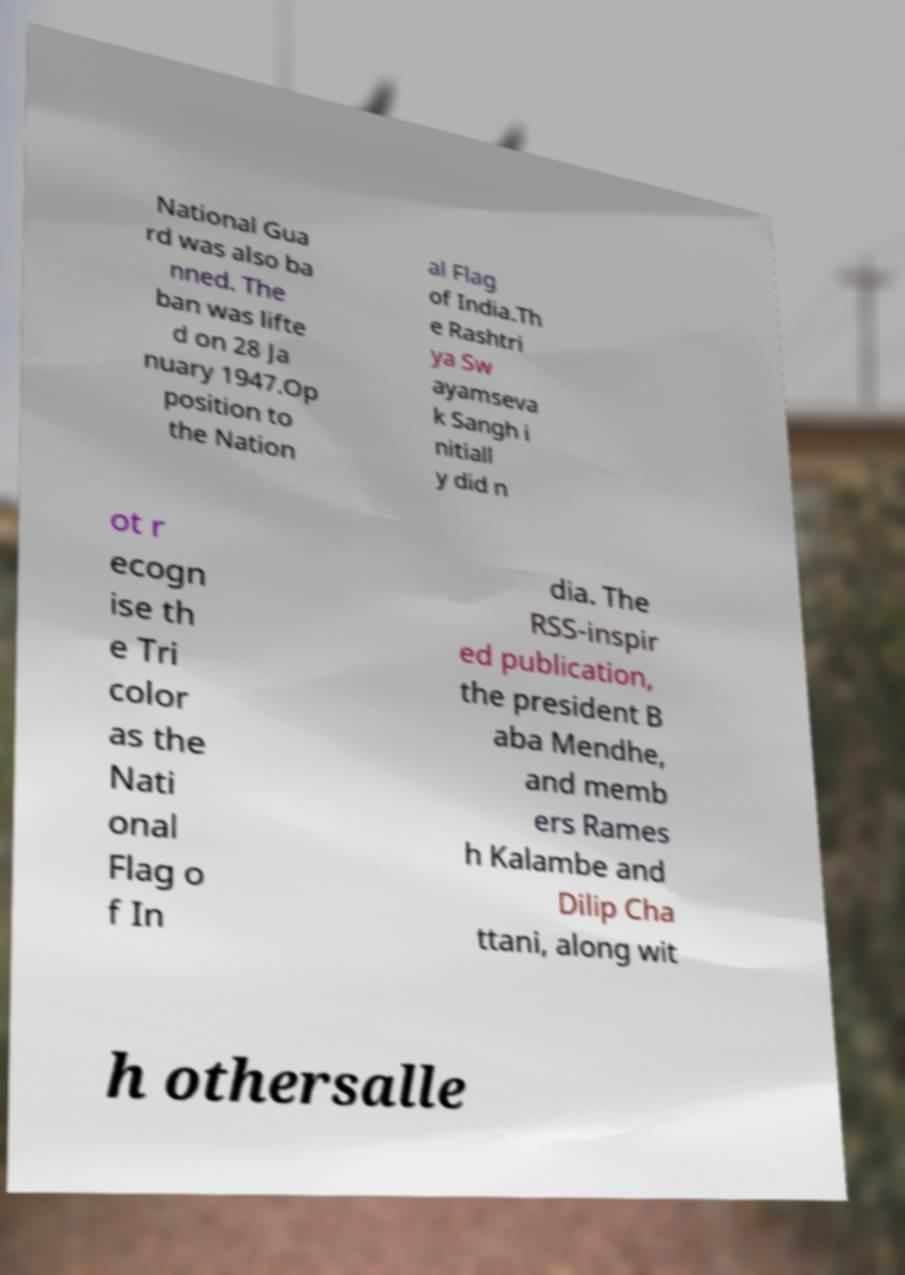For documentation purposes, I need the text within this image transcribed. Could you provide that? National Gua rd was also ba nned. The ban was lifte d on 28 Ja nuary 1947.Op position to the Nation al Flag of India.Th e Rashtri ya Sw ayamseva k Sangh i nitiall y did n ot r ecogn ise th e Tri color as the Nati onal Flag o f In dia. The RSS-inspir ed publication, the president B aba Mendhe, and memb ers Rames h Kalambe and Dilip Cha ttani, along wit h othersalle 